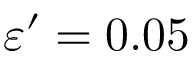Convert formula to latex. <formula><loc_0><loc_0><loc_500><loc_500>\varepsilon ^ { \prime } = 0 . 0 5</formula> 